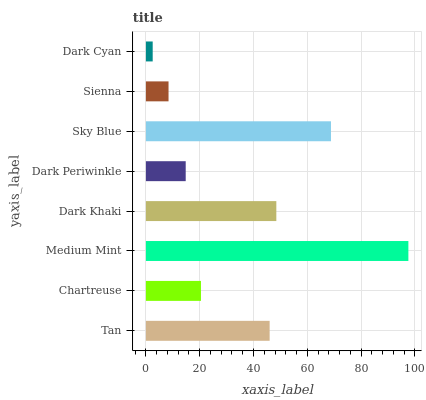Is Dark Cyan the minimum?
Answer yes or no. Yes. Is Medium Mint the maximum?
Answer yes or no. Yes. Is Chartreuse the minimum?
Answer yes or no. No. Is Chartreuse the maximum?
Answer yes or no. No. Is Tan greater than Chartreuse?
Answer yes or no. Yes. Is Chartreuse less than Tan?
Answer yes or no. Yes. Is Chartreuse greater than Tan?
Answer yes or no. No. Is Tan less than Chartreuse?
Answer yes or no. No. Is Tan the high median?
Answer yes or no. Yes. Is Chartreuse the low median?
Answer yes or no. Yes. Is Dark Khaki the high median?
Answer yes or no. No. Is Dark Periwinkle the low median?
Answer yes or no. No. 